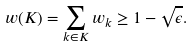<formula> <loc_0><loc_0><loc_500><loc_500>w ( K ) = \sum _ { k \in K } w _ { k } \geq 1 - \sqrt { \epsilon } .</formula> 